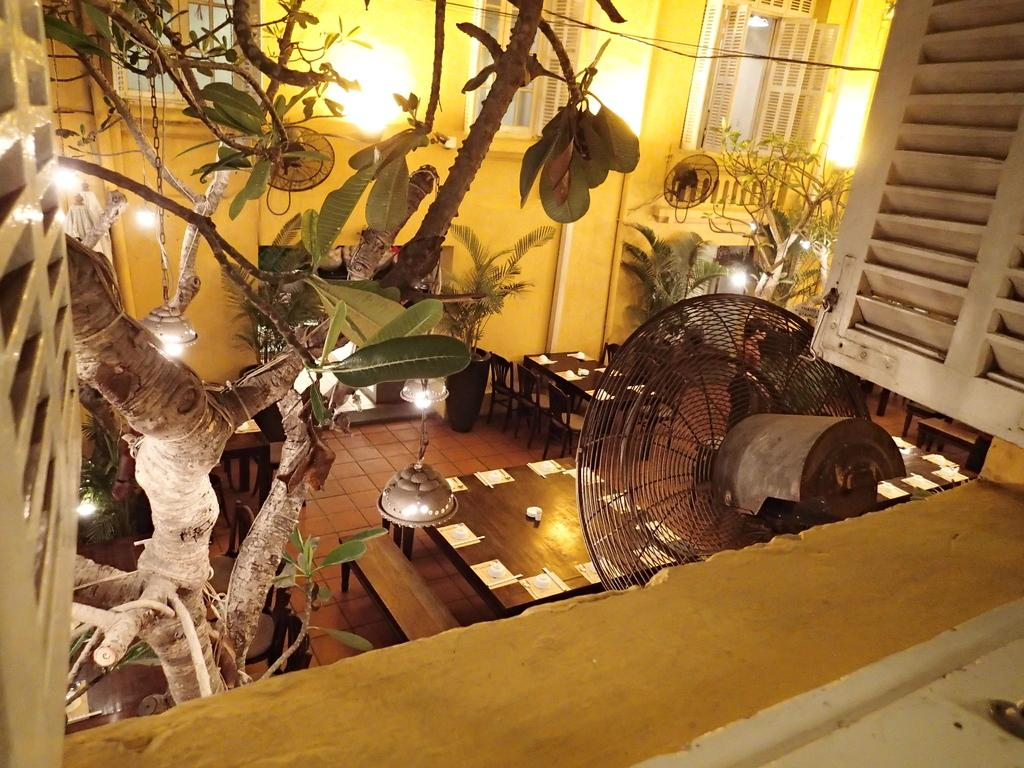What type of objects can be seen in the image? There are plants, lights, fans, tables, and chairs in the image. What is on the tables in the image? There are papers and other things on the tables in the image. Can you describe the lighting in the image? Yes, there are lights visible in the image. What type of furniture is present in the image? Tables and chairs are present in the image. What type of cabbage is being used as a science experiment on the table in the image? There is no cabbage or science experiment present in the image. Can you tell me how many bones are visible on the table in the image? There are no bones visible on the table in the image. 